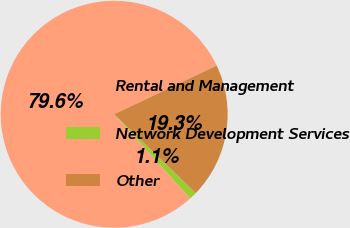<chart> <loc_0><loc_0><loc_500><loc_500><pie_chart><fcel>Rental and Management<fcel>Network Development Services<fcel>Other<nl><fcel>79.64%<fcel>1.09%<fcel>19.27%<nl></chart> 